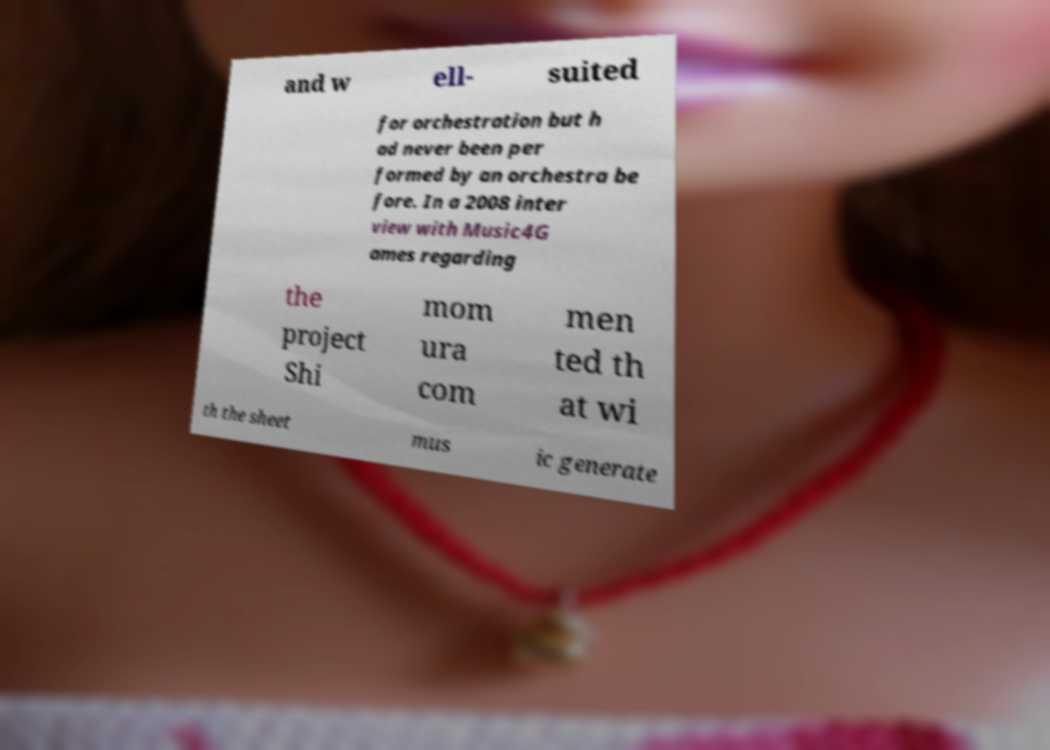Could you assist in decoding the text presented in this image and type it out clearly? and w ell- suited for orchestration but h ad never been per formed by an orchestra be fore. In a 2008 inter view with Music4G ames regarding the project Shi mom ura com men ted th at wi th the sheet mus ic generate 